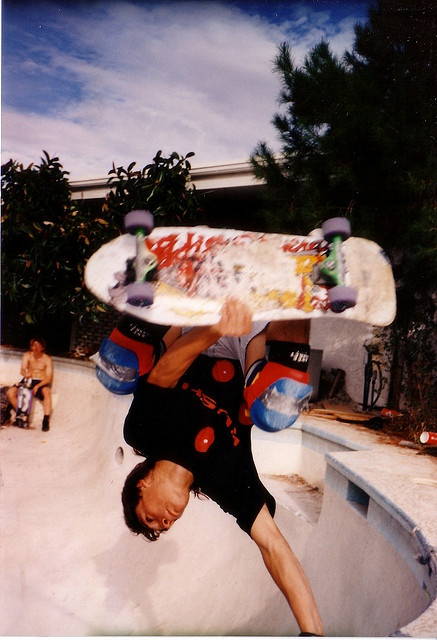Describe the objects in this image and their specific colors. I can see people in white, black, maroon, and salmon tones, skateboard in white, lightgray, tan, and darkgray tones, people in white, black, salmon, and brown tones, and skateboard in white, brown, black, maroon, and pink tones in this image. 